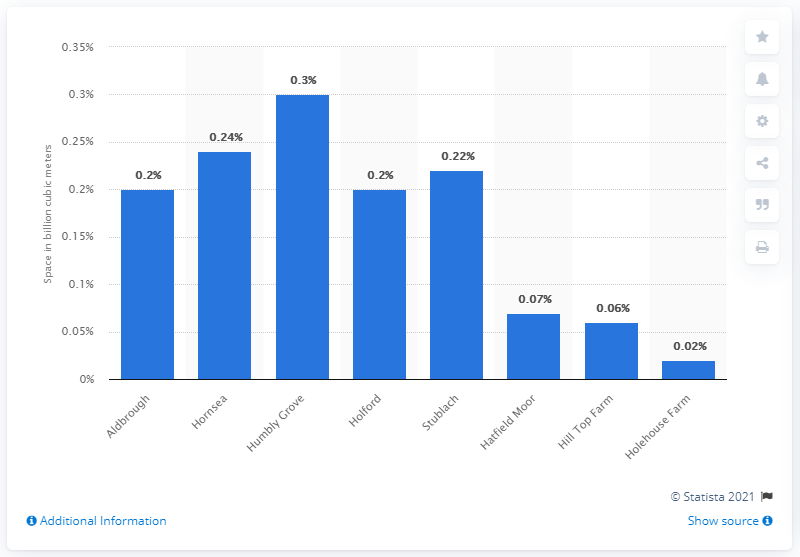Give some essential details in this illustration. I request that the sites be ranked in order of size, with the largest site being at least 12 times the size of the smallest site, which includes Humbly Grove and Hornsea. When the rightmost bar is deducted from the leftmost bar, the result is 0.18. The storage capacity of Aldbrough was approximately 0.2 cubic meters. 